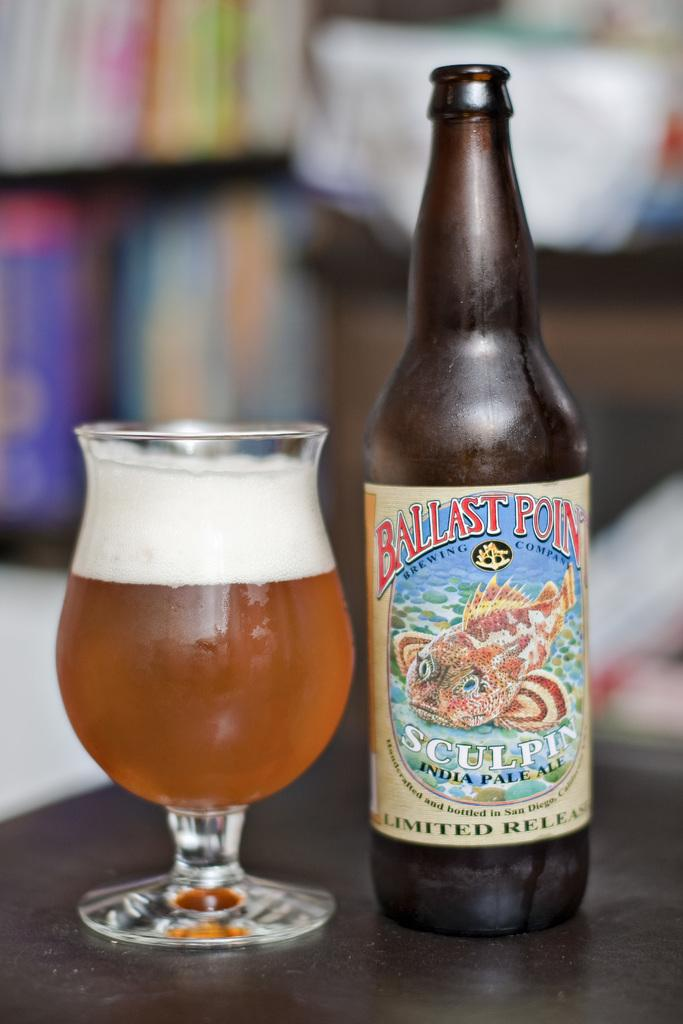Provide a one-sentence caption for the provided image. A limited release of Ballast Point beer is on the table. 